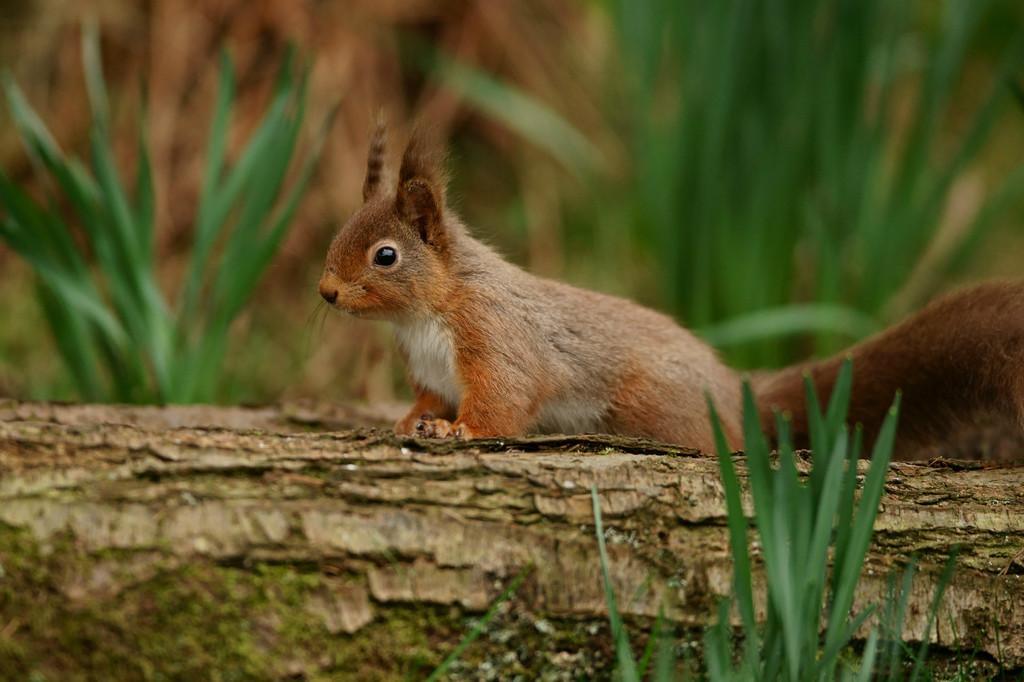Describe this image in one or two sentences. In the image we can see the squirrel on the wooden log. Here we can see the grass and the background is slightly blurred. 